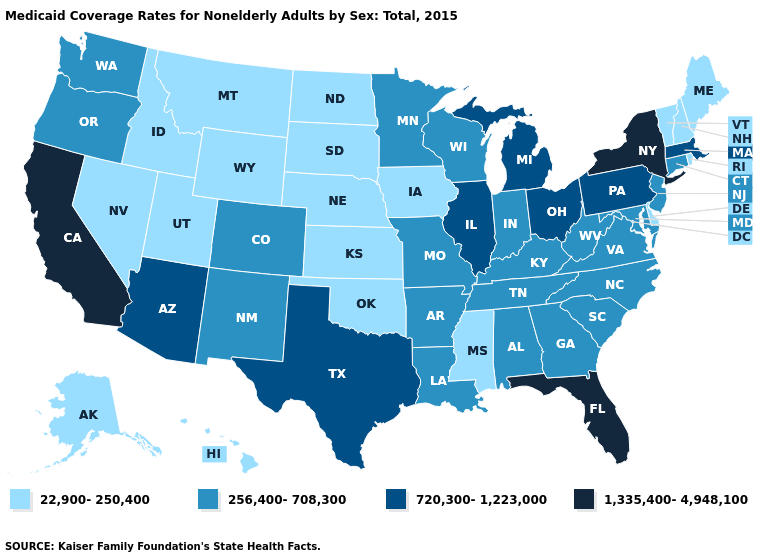Name the states that have a value in the range 720,300-1,223,000?
Give a very brief answer. Arizona, Illinois, Massachusetts, Michigan, Ohio, Pennsylvania, Texas. Does South Carolina have a lower value than Oklahoma?
Write a very short answer. No. Which states hav the highest value in the South?
Quick response, please. Florida. Among the states that border Louisiana , which have the lowest value?
Quick response, please. Mississippi. Name the states that have a value in the range 22,900-250,400?
Keep it brief. Alaska, Delaware, Hawaii, Idaho, Iowa, Kansas, Maine, Mississippi, Montana, Nebraska, Nevada, New Hampshire, North Dakota, Oklahoma, Rhode Island, South Dakota, Utah, Vermont, Wyoming. Name the states that have a value in the range 720,300-1,223,000?
Write a very short answer. Arizona, Illinois, Massachusetts, Michigan, Ohio, Pennsylvania, Texas. Does Minnesota have the highest value in the USA?
Write a very short answer. No. Does the first symbol in the legend represent the smallest category?
Give a very brief answer. Yes. Name the states that have a value in the range 1,335,400-4,948,100?
Answer briefly. California, Florida, New York. What is the lowest value in states that border Arizona?
Give a very brief answer. 22,900-250,400. Does Kansas have the lowest value in the MidWest?
Give a very brief answer. Yes. Does Alabama have a lower value than Ohio?
Give a very brief answer. Yes. Name the states that have a value in the range 720,300-1,223,000?
Give a very brief answer. Arizona, Illinois, Massachusetts, Michigan, Ohio, Pennsylvania, Texas. Which states have the lowest value in the USA?
Concise answer only. Alaska, Delaware, Hawaii, Idaho, Iowa, Kansas, Maine, Mississippi, Montana, Nebraska, Nevada, New Hampshire, North Dakota, Oklahoma, Rhode Island, South Dakota, Utah, Vermont, Wyoming. Which states have the highest value in the USA?
Short answer required. California, Florida, New York. 